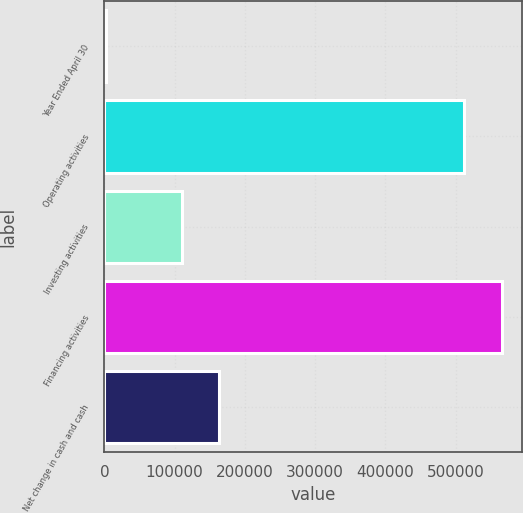Convert chart to OTSL. <chart><loc_0><loc_0><loc_500><loc_500><bar_chart><fcel>Year Ended April 30<fcel>Operating activities<fcel>Investing activities<fcel>Financing activities<fcel>Net change in cash and cash<nl><fcel>2011<fcel>512503<fcel>110157<fcel>565741<fcel>163395<nl></chart> 